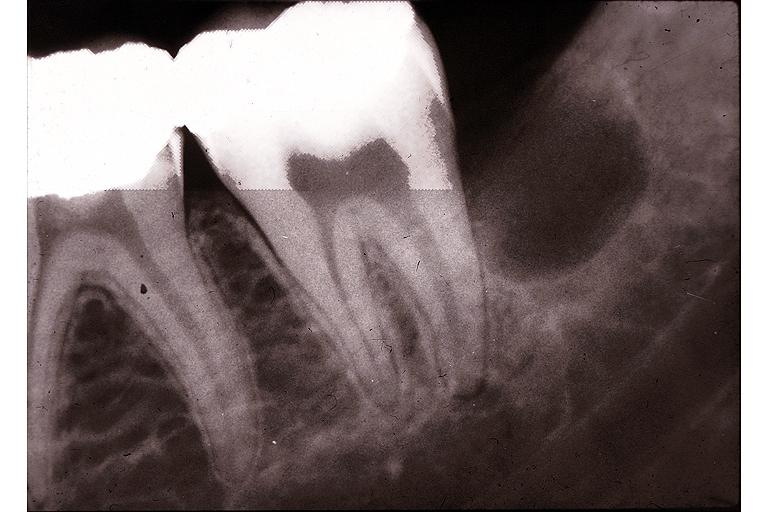what does this image show?
Answer the question using a single word or phrase. Primodial cyst 